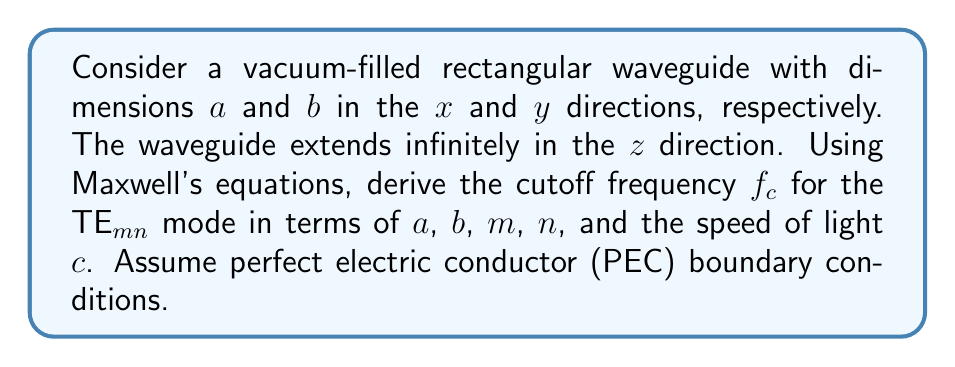Can you solve this math problem? To solve this problem, we'll follow these steps:

1) Recall Maxwell's equations in a source-free region:

   $$\nabla \times \mathbf{E} = -\frac{\partial \mathbf{B}}{\partial t}$$
   $$\nabla \times \mathbf{H} = \frac{\partial \mathbf{D}}{\partial t}$$
   $$\nabla \cdot \mathbf{D} = 0$$
   $$\nabla \cdot \mathbf{B} = 0$$

2) For TE modes, $E_z = 0$. We can express the electric field as:

   $$\mathbf{E} = (E_x, E_y, 0)$$

3) The wave equation for the magnetic field in a source-free region is:

   $$\nabla^2\mathbf{H} - \mu\epsilon\frac{\partial^2\mathbf{H}}{\partial t^2} = 0$$

4) For the TE$_{mn}$ mode, we can express $H_z$ as:

   $$H_z = H_0 \cos(\frac{m\pi x}{a}) \cos(\frac{n\pi y}{b}) e^{j(\omega t - \beta z)}$$

   where $m$ and $n$ are non-negative integers, and not both zero.

5) Substituting this into the wave equation:

   $$-(\frac{m\pi}{a})^2 - (\frac{n\pi}{b})^2 - \beta^2 + \omega^2\mu\epsilon = 0$$

6) The cutoff frequency occurs when $\beta = 0$. Setting $\beta = 0$ and solving for $\omega$:

   $$\omega_c^2 = (\frac{m\pi}{a})^2 + (\frac{n\pi}{b})^2$$

7) Convert angular frequency to regular frequency using $f = \omega/(2\pi)$, and substitute $c = 1/\sqrt{\mu\epsilon}$:

   $$f_c = \frac{c}{2} \sqrt{(\frac{m}{a})^2 + (\frac{n}{b})^2}$$

This is the cutoff frequency for the TE$_{mn}$ mode in the rectangular waveguide.
Answer: $$f_c = \frac{c}{2} \sqrt{(\frac{m}{a})^2 + (\frac{n}{b})^2}$$ 